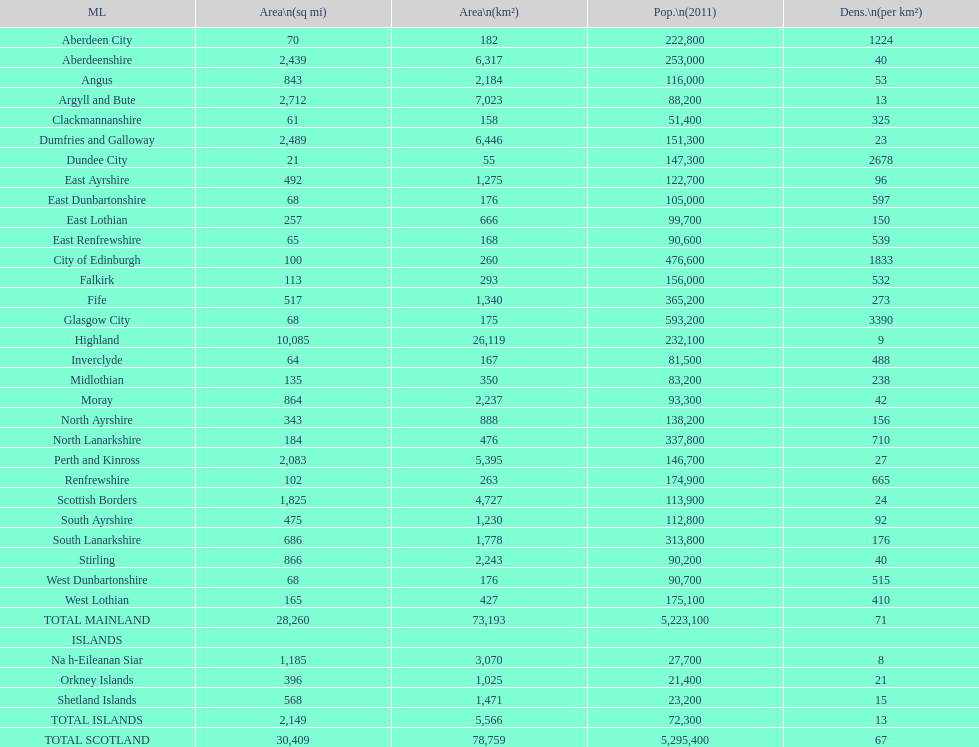What is the total area of east lothian, angus, and dundee city? 1121. 